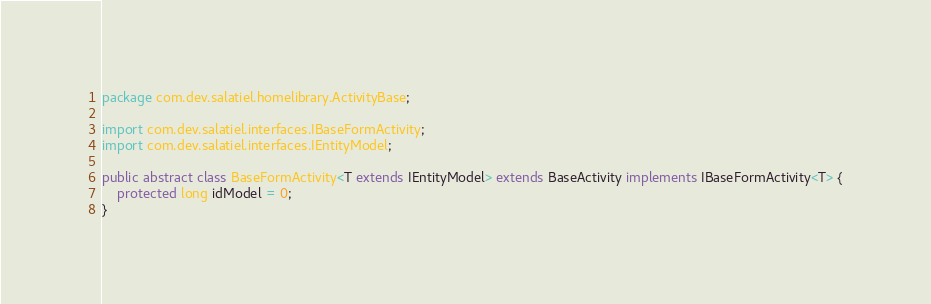<code> <loc_0><loc_0><loc_500><loc_500><_Java_>package com.dev.salatiel.homelibrary.ActivityBase;

import com.dev.salatiel.interfaces.IBaseFormActivity;
import com.dev.salatiel.interfaces.IEntityModel;

public abstract class BaseFormActivity<T extends IEntityModel> extends BaseActivity implements IBaseFormActivity<T> {
    protected long idModel = 0;
}
</code> 